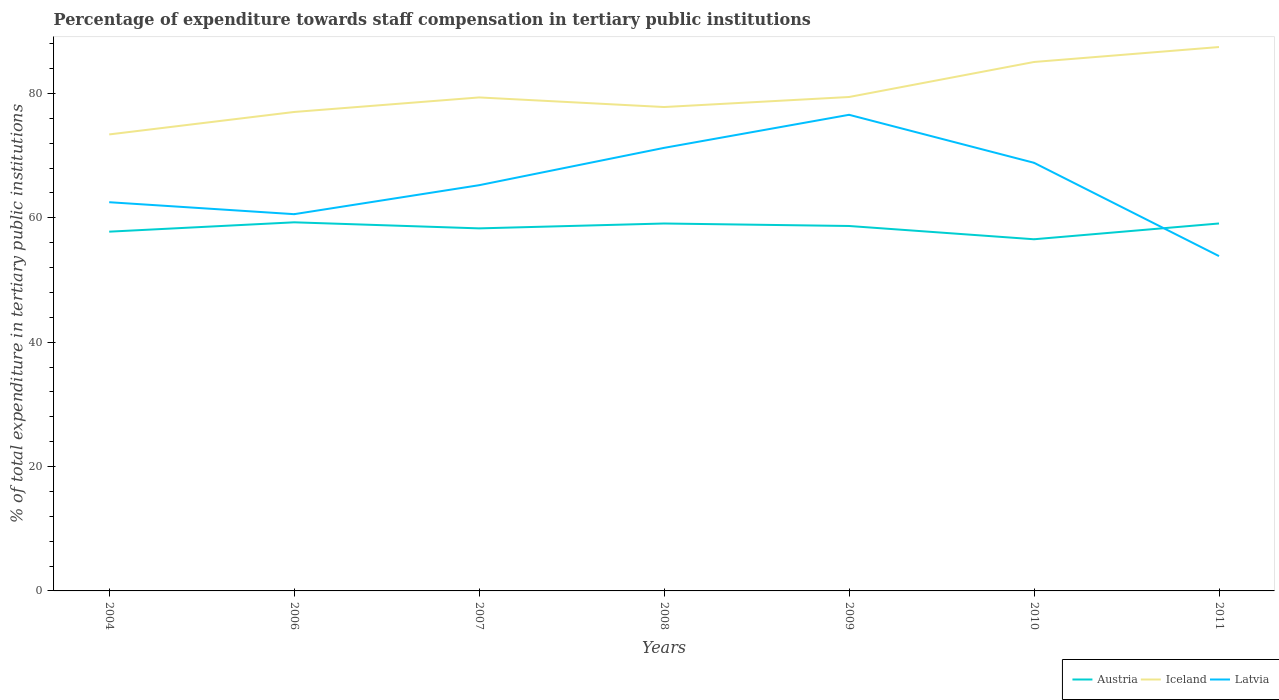How many different coloured lines are there?
Give a very brief answer. 3. Does the line corresponding to Iceland intersect with the line corresponding to Austria?
Provide a succinct answer. No. Across all years, what is the maximum percentage of expenditure towards staff compensation in Iceland?
Provide a short and direct response. 73.4. What is the total percentage of expenditure towards staff compensation in Iceland in the graph?
Make the answer very short. 1.54. What is the difference between the highest and the second highest percentage of expenditure towards staff compensation in Latvia?
Provide a succinct answer. 22.72. What is the difference between the highest and the lowest percentage of expenditure towards staff compensation in Austria?
Your answer should be very brief. 4. Is the percentage of expenditure towards staff compensation in Latvia strictly greater than the percentage of expenditure towards staff compensation in Austria over the years?
Offer a very short reply. No. How many lines are there?
Your answer should be very brief. 3. How many years are there in the graph?
Make the answer very short. 7. Does the graph contain any zero values?
Your response must be concise. No. Does the graph contain grids?
Make the answer very short. No. Where does the legend appear in the graph?
Your response must be concise. Bottom right. What is the title of the graph?
Offer a very short reply. Percentage of expenditure towards staff compensation in tertiary public institutions. What is the label or title of the X-axis?
Ensure brevity in your answer.  Years. What is the label or title of the Y-axis?
Your answer should be compact. % of total expenditure in tertiary public institutions. What is the % of total expenditure in tertiary public institutions in Austria in 2004?
Your answer should be compact. 57.76. What is the % of total expenditure in tertiary public institutions in Iceland in 2004?
Your answer should be compact. 73.4. What is the % of total expenditure in tertiary public institutions of Latvia in 2004?
Your answer should be very brief. 62.5. What is the % of total expenditure in tertiary public institutions in Austria in 2006?
Your answer should be very brief. 59.27. What is the % of total expenditure in tertiary public institutions in Iceland in 2006?
Ensure brevity in your answer.  77.01. What is the % of total expenditure in tertiary public institutions in Latvia in 2006?
Your answer should be very brief. 60.58. What is the % of total expenditure in tertiary public institutions in Austria in 2007?
Give a very brief answer. 58.29. What is the % of total expenditure in tertiary public institutions in Iceland in 2007?
Provide a short and direct response. 79.35. What is the % of total expenditure in tertiary public institutions in Latvia in 2007?
Your response must be concise. 65.24. What is the % of total expenditure in tertiary public institutions in Austria in 2008?
Provide a short and direct response. 59.08. What is the % of total expenditure in tertiary public institutions in Iceland in 2008?
Ensure brevity in your answer.  77.8. What is the % of total expenditure in tertiary public institutions of Latvia in 2008?
Your answer should be very brief. 71.24. What is the % of total expenditure in tertiary public institutions in Austria in 2009?
Your answer should be very brief. 58.68. What is the % of total expenditure in tertiary public institutions in Iceland in 2009?
Ensure brevity in your answer.  79.42. What is the % of total expenditure in tertiary public institutions of Latvia in 2009?
Your answer should be very brief. 76.56. What is the % of total expenditure in tertiary public institutions in Austria in 2010?
Your answer should be compact. 56.54. What is the % of total expenditure in tertiary public institutions in Iceland in 2010?
Provide a succinct answer. 85.05. What is the % of total expenditure in tertiary public institutions of Latvia in 2010?
Give a very brief answer. 68.84. What is the % of total expenditure in tertiary public institutions of Austria in 2011?
Your response must be concise. 59.08. What is the % of total expenditure in tertiary public institutions of Iceland in 2011?
Your answer should be very brief. 87.45. What is the % of total expenditure in tertiary public institutions of Latvia in 2011?
Your response must be concise. 53.84. Across all years, what is the maximum % of total expenditure in tertiary public institutions of Austria?
Your answer should be compact. 59.27. Across all years, what is the maximum % of total expenditure in tertiary public institutions in Iceland?
Ensure brevity in your answer.  87.45. Across all years, what is the maximum % of total expenditure in tertiary public institutions of Latvia?
Ensure brevity in your answer.  76.56. Across all years, what is the minimum % of total expenditure in tertiary public institutions in Austria?
Provide a short and direct response. 56.54. Across all years, what is the minimum % of total expenditure in tertiary public institutions of Iceland?
Ensure brevity in your answer.  73.4. Across all years, what is the minimum % of total expenditure in tertiary public institutions in Latvia?
Offer a terse response. 53.84. What is the total % of total expenditure in tertiary public institutions of Austria in the graph?
Offer a very short reply. 408.7. What is the total % of total expenditure in tertiary public institutions in Iceland in the graph?
Make the answer very short. 559.48. What is the total % of total expenditure in tertiary public institutions of Latvia in the graph?
Give a very brief answer. 458.78. What is the difference between the % of total expenditure in tertiary public institutions of Austria in 2004 and that in 2006?
Give a very brief answer. -1.5. What is the difference between the % of total expenditure in tertiary public institutions of Iceland in 2004 and that in 2006?
Make the answer very short. -3.61. What is the difference between the % of total expenditure in tertiary public institutions of Latvia in 2004 and that in 2006?
Offer a terse response. 1.92. What is the difference between the % of total expenditure in tertiary public institutions of Austria in 2004 and that in 2007?
Keep it short and to the point. -0.53. What is the difference between the % of total expenditure in tertiary public institutions of Iceland in 2004 and that in 2007?
Give a very brief answer. -5.95. What is the difference between the % of total expenditure in tertiary public institutions in Latvia in 2004 and that in 2007?
Give a very brief answer. -2.74. What is the difference between the % of total expenditure in tertiary public institutions of Austria in 2004 and that in 2008?
Your response must be concise. -1.31. What is the difference between the % of total expenditure in tertiary public institutions in Iceland in 2004 and that in 2008?
Provide a succinct answer. -4.41. What is the difference between the % of total expenditure in tertiary public institutions of Latvia in 2004 and that in 2008?
Keep it short and to the point. -8.74. What is the difference between the % of total expenditure in tertiary public institutions of Austria in 2004 and that in 2009?
Ensure brevity in your answer.  -0.91. What is the difference between the % of total expenditure in tertiary public institutions of Iceland in 2004 and that in 2009?
Offer a terse response. -6.02. What is the difference between the % of total expenditure in tertiary public institutions in Latvia in 2004 and that in 2009?
Your answer should be compact. -14.06. What is the difference between the % of total expenditure in tertiary public institutions in Austria in 2004 and that in 2010?
Give a very brief answer. 1.22. What is the difference between the % of total expenditure in tertiary public institutions in Iceland in 2004 and that in 2010?
Offer a very short reply. -11.65. What is the difference between the % of total expenditure in tertiary public institutions in Latvia in 2004 and that in 2010?
Ensure brevity in your answer.  -6.34. What is the difference between the % of total expenditure in tertiary public institutions in Austria in 2004 and that in 2011?
Provide a succinct answer. -1.32. What is the difference between the % of total expenditure in tertiary public institutions in Iceland in 2004 and that in 2011?
Make the answer very short. -14.05. What is the difference between the % of total expenditure in tertiary public institutions of Latvia in 2004 and that in 2011?
Provide a short and direct response. 8.66. What is the difference between the % of total expenditure in tertiary public institutions of Austria in 2006 and that in 2007?
Keep it short and to the point. 0.97. What is the difference between the % of total expenditure in tertiary public institutions of Iceland in 2006 and that in 2007?
Ensure brevity in your answer.  -2.34. What is the difference between the % of total expenditure in tertiary public institutions of Latvia in 2006 and that in 2007?
Your response must be concise. -4.66. What is the difference between the % of total expenditure in tertiary public institutions in Austria in 2006 and that in 2008?
Your answer should be compact. 0.19. What is the difference between the % of total expenditure in tertiary public institutions of Iceland in 2006 and that in 2008?
Provide a short and direct response. -0.79. What is the difference between the % of total expenditure in tertiary public institutions of Latvia in 2006 and that in 2008?
Offer a very short reply. -10.66. What is the difference between the % of total expenditure in tertiary public institutions in Austria in 2006 and that in 2009?
Make the answer very short. 0.59. What is the difference between the % of total expenditure in tertiary public institutions of Iceland in 2006 and that in 2009?
Your answer should be compact. -2.41. What is the difference between the % of total expenditure in tertiary public institutions in Latvia in 2006 and that in 2009?
Your response must be concise. -15.98. What is the difference between the % of total expenditure in tertiary public institutions in Austria in 2006 and that in 2010?
Keep it short and to the point. 2.72. What is the difference between the % of total expenditure in tertiary public institutions of Iceland in 2006 and that in 2010?
Make the answer very short. -8.04. What is the difference between the % of total expenditure in tertiary public institutions in Latvia in 2006 and that in 2010?
Make the answer very short. -8.26. What is the difference between the % of total expenditure in tertiary public institutions in Austria in 2006 and that in 2011?
Your answer should be compact. 0.19. What is the difference between the % of total expenditure in tertiary public institutions in Iceland in 2006 and that in 2011?
Provide a short and direct response. -10.44. What is the difference between the % of total expenditure in tertiary public institutions of Latvia in 2006 and that in 2011?
Your response must be concise. 6.74. What is the difference between the % of total expenditure in tertiary public institutions in Austria in 2007 and that in 2008?
Your answer should be compact. -0.78. What is the difference between the % of total expenditure in tertiary public institutions of Iceland in 2007 and that in 2008?
Your answer should be compact. 1.54. What is the difference between the % of total expenditure in tertiary public institutions of Latvia in 2007 and that in 2008?
Your answer should be compact. -6. What is the difference between the % of total expenditure in tertiary public institutions in Austria in 2007 and that in 2009?
Provide a succinct answer. -0.38. What is the difference between the % of total expenditure in tertiary public institutions in Iceland in 2007 and that in 2009?
Your answer should be compact. -0.07. What is the difference between the % of total expenditure in tertiary public institutions of Latvia in 2007 and that in 2009?
Your response must be concise. -11.32. What is the difference between the % of total expenditure in tertiary public institutions in Austria in 2007 and that in 2010?
Keep it short and to the point. 1.75. What is the difference between the % of total expenditure in tertiary public institutions of Iceland in 2007 and that in 2010?
Provide a succinct answer. -5.7. What is the difference between the % of total expenditure in tertiary public institutions in Latvia in 2007 and that in 2010?
Provide a short and direct response. -3.6. What is the difference between the % of total expenditure in tertiary public institutions of Austria in 2007 and that in 2011?
Your response must be concise. -0.79. What is the difference between the % of total expenditure in tertiary public institutions in Iceland in 2007 and that in 2011?
Your answer should be compact. -8.1. What is the difference between the % of total expenditure in tertiary public institutions of Latvia in 2007 and that in 2011?
Provide a short and direct response. 11.4. What is the difference between the % of total expenditure in tertiary public institutions in Austria in 2008 and that in 2009?
Offer a very short reply. 0.4. What is the difference between the % of total expenditure in tertiary public institutions of Iceland in 2008 and that in 2009?
Your answer should be very brief. -1.61. What is the difference between the % of total expenditure in tertiary public institutions of Latvia in 2008 and that in 2009?
Offer a terse response. -5.32. What is the difference between the % of total expenditure in tertiary public institutions of Austria in 2008 and that in 2010?
Keep it short and to the point. 2.53. What is the difference between the % of total expenditure in tertiary public institutions of Iceland in 2008 and that in 2010?
Your response must be concise. -7.24. What is the difference between the % of total expenditure in tertiary public institutions of Latvia in 2008 and that in 2010?
Your answer should be very brief. 2.4. What is the difference between the % of total expenditure in tertiary public institutions of Austria in 2008 and that in 2011?
Your answer should be very brief. -0. What is the difference between the % of total expenditure in tertiary public institutions in Iceland in 2008 and that in 2011?
Your answer should be compact. -9.65. What is the difference between the % of total expenditure in tertiary public institutions of Latvia in 2008 and that in 2011?
Your answer should be compact. 17.4. What is the difference between the % of total expenditure in tertiary public institutions of Austria in 2009 and that in 2010?
Your answer should be very brief. 2.13. What is the difference between the % of total expenditure in tertiary public institutions of Iceland in 2009 and that in 2010?
Keep it short and to the point. -5.63. What is the difference between the % of total expenditure in tertiary public institutions of Latvia in 2009 and that in 2010?
Ensure brevity in your answer.  7.72. What is the difference between the % of total expenditure in tertiary public institutions in Austria in 2009 and that in 2011?
Your answer should be very brief. -0.4. What is the difference between the % of total expenditure in tertiary public institutions of Iceland in 2009 and that in 2011?
Your answer should be very brief. -8.04. What is the difference between the % of total expenditure in tertiary public institutions in Latvia in 2009 and that in 2011?
Your response must be concise. 22.72. What is the difference between the % of total expenditure in tertiary public institutions in Austria in 2010 and that in 2011?
Your response must be concise. -2.54. What is the difference between the % of total expenditure in tertiary public institutions in Iceland in 2010 and that in 2011?
Give a very brief answer. -2.4. What is the difference between the % of total expenditure in tertiary public institutions in Latvia in 2010 and that in 2011?
Offer a terse response. 15. What is the difference between the % of total expenditure in tertiary public institutions in Austria in 2004 and the % of total expenditure in tertiary public institutions in Iceland in 2006?
Provide a succinct answer. -19.25. What is the difference between the % of total expenditure in tertiary public institutions of Austria in 2004 and the % of total expenditure in tertiary public institutions of Latvia in 2006?
Give a very brief answer. -2.81. What is the difference between the % of total expenditure in tertiary public institutions of Iceland in 2004 and the % of total expenditure in tertiary public institutions of Latvia in 2006?
Your response must be concise. 12.82. What is the difference between the % of total expenditure in tertiary public institutions in Austria in 2004 and the % of total expenditure in tertiary public institutions in Iceland in 2007?
Offer a terse response. -21.58. What is the difference between the % of total expenditure in tertiary public institutions of Austria in 2004 and the % of total expenditure in tertiary public institutions of Latvia in 2007?
Offer a terse response. -7.47. What is the difference between the % of total expenditure in tertiary public institutions of Iceland in 2004 and the % of total expenditure in tertiary public institutions of Latvia in 2007?
Give a very brief answer. 8.16. What is the difference between the % of total expenditure in tertiary public institutions of Austria in 2004 and the % of total expenditure in tertiary public institutions of Iceland in 2008?
Your answer should be compact. -20.04. What is the difference between the % of total expenditure in tertiary public institutions of Austria in 2004 and the % of total expenditure in tertiary public institutions of Latvia in 2008?
Give a very brief answer. -13.48. What is the difference between the % of total expenditure in tertiary public institutions of Iceland in 2004 and the % of total expenditure in tertiary public institutions of Latvia in 2008?
Provide a succinct answer. 2.16. What is the difference between the % of total expenditure in tertiary public institutions in Austria in 2004 and the % of total expenditure in tertiary public institutions in Iceland in 2009?
Give a very brief answer. -21.65. What is the difference between the % of total expenditure in tertiary public institutions of Austria in 2004 and the % of total expenditure in tertiary public institutions of Latvia in 2009?
Keep it short and to the point. -18.79. What is the difference between the % of total expenditure in tertiary public institutions in Iceland in 2004 and the % of total expenditure in tertiary public institutions in Latvia in 2009?
Provide a succinct answer. -3.16. What is the difference between the % of total expenditure in tertiary public institutions of Austria in 2004 and the % of total expenditure in tertiary public institutions of Iceland in 2010?
Keep it short and to the point. -27.28. What is the difference between the % of total expenditure in tertiary public institutions of Austria in 2004 and the % of total expenditure in tertiary public institutions of Latvia in 2010?
Make the answer very short. -11.07. What is the difference between the % of total expenditure in tertiary public institutions of Iceland in 2004 and the % of total expenditure in tertiary public institutions of Latvia in 2010?
Offer a terse response. 4.56. What is the difference between the % of total expenditure in tertiary public institutions of Austria in 2004 and the % of total expenditure in tertiary public institutions of Iceland in 2011?
Offer a terse response. -29.69. What is the difference between the % of total expenditure in tertiary public institutions of Austria in 2004 and the % of total expenditure in tertiary public institutions of Latvia in 2011?
Make the answer very short. 3.93. What is the difference between the % of total expenditure in tertiary public institutions in Iceland in 2004 and the % of total expenditure in tertiary public institutions in Latvia in 2011?
Your answer should be compact. 19.56. What is the difference between the % of total expenditure in tertiary public institutions in Austria in 2006 and the % of total expenditure in tertiary public institutions in Iceland in 2007?
Keep it short and to the point. -20.08. What is the difference between the % of total expenditure in tertiary public institutions of Austria in 2006 and the % of total expenditure in tertiary public institutions of Latvia in 2007?
Offer a terse response. -5.97. What is the difference between the % of total expenditure in tertiary public institutions of Iceland in 2006 and the % of total expenditure in tertiary public institutions of Latvia in 2007?
Keep it short and to the point. 11.77. What is the difference between the % of total expenditure in tertiary public institutions of Austria in 2006 and the % of total expenditure in tertiary public institutions of Iceland in 2008?
Provide a short and direct response. -18.54. What is the difference between the % of total expenditure in tertiary public institutions in Austria in 2006 and the % of total expenditure in tertiary public institutions in Latvia in 2008?
Your answer should be compact. -11.97. What is the difference between the % of total expenditure in tertiary public institutions in Iceland in 2006 and the % of total expenditure in tertiary public institutions in Latvia in 2008?
Your response must be concise. 5.77. What is the difference between the % of total expenditure in tertiary public institutions in Austria in 2006 and the % of total expenditure in tertiary public institutions in Iceland in 2009?
Your answer should be compact. -20.15. What is the difference between the % of total expenditure in tertiary public institutions in Austria in 2006 and the % of total expenditure in tertiary public institutions in Latvia in 2009?
Your response must be concise. -17.29. What is the difference between the % of total expenditure in tertiary public institutions in Iceland in 2006 and the % of total expenditure in tertiary public institutions in Latvia in 2009?
Ensure brevity in your answer.  0.45. What is the difference between the % of total expenditure in tertiary public institutions of Austria in 2006 and the % of total expenditure in tertiary public institutions of Iceland in 2010?
Offer a very short reply. -25.78. What is the difference between the % of total expenditure in tertiary public institutions in Austria in 2006 and the % of total expenditure in tertiary public institutions in Latvia in 2010?
Provide a succinct answer. -9.57. What is the difference between the % of total expenditure in tertiary public institutions in Iceland in 2006 and the % of total expenditure in tertiary public institutions in Latvia in 2010?
Make the answer very short. 8.17. What is the difference between the % of total expenditure in tertiary public institutions in Austria in 2006 and the % of total expenditure in tertiary public institutions in Iceland in 2011?
Provide a short and direct response. -28.18. What is the difference between the % of total expenditure in tertiary public institutions of Austria in 2006 and the % of total expenditure in tertiary public institutions of Latvia in 2011?
Offer a terse response. 5.43. What is the difference between the % of total expenditure in tertiary public institutions of Iceland in 2006 and the % of total expenditure in tertiary public institutions of Latvia in 2011?
Offer a very short reply. 23.17. What is the difference between the % of total expenditure in tertiary public institutions in Austria in 2007 and the % of total expenditure in tertiary public institutions in Iceland in 2008?
Keep it short and to the point. -19.51. What is the difference between the % of total expenditure in tertiary public institutions of Austria in 2007 and the % of total expenditure in tertiary public institutions of Latvia in 2008?
Your response must be concise. -12.95. What is the difference between the % of total expenditure in tertiary public institutions of Iceland in 2007 and the % of total expenditure in tertiary public institutions of Latvia in 2008?
Ensure brevity in your answer.  8.11. What is the difference between the % of total expenditure in tertiary public institutions in Austria in 2007 and the % of total expenditure in tertiary public institutions in Iceland in 2009?
Offer a terse response. -21.12. What is the difference between the % of total expenditure in tertiary public institutions of Austria in 2007 and the % of total expenditure in tertiary public institutions of Latvia in 2009?
Provide a short and direct response. -18.26. What is the difference between the % of total expenditure in tertiary public institutions in Iceland in 2007 and the % of total expenditure in tertiary public institutions in Latvia in 2009?
Give a very brief answer. 2.79. What is the difference between the % of total expenditure in tertiary public institutions in Austria in 2007 and the % of total expenditure in tertiary public institutions in Iceland in 2010?
Your response must be concise. -26.75. What is the difference between the % of total expenditure in tertiary public institutions of Austria in 2007 and the % of total expenditure in tertiary public institutions of Latvia in 2010?
Make the answer very short. -10.54. What is the difference between the % of total expenditure in tertiary public institutions of Iceland in 2007 and the % of total expenditure in tertiary public institutions of Latvia in 2010?
Offer a very short reply. 10.51. What is the difference between the % of total expenditure in tertiary public institutions in Austria in 2007 and the % of total expenditure in tertiary public institutions in Iceland in 2011?
Provide a succinct answer. -29.16. What is the difference between the % of total expenditure in tertiary public institutions of Austria in 2007 and the % of total expenditure in tertiary public institutions of Latvia in 2011?
Offer a very short reply. 4.46. What is the difference between the % of total expenditure in tertiary public institutions in Iceland in 2007 and the % of total expenditure in tertiary public institutions in Latvia in 2011?
Offer a very short reply. 25.51. What is the difference between the % of total expenditure in tertiary public institutions in Austria in 2008 and the % of total expenditure in tertiary public institutions in Iceland in 2009?
Your answer should be compact. -20.34. What is the difference between the % of total expenditure in tertiary public institutions in Austria in 2008 and the % of total expenditure in tertiary public institutions in Latvia in 2009?
Offer a very short reply. -17.48. What is the difference between the % of total expenditure in tertiary public institutions in Iceland in 2008 and the % of total expenditure in tertiary public institutions in Latvia in 2009?
Offer a very short reply. 1.25. What is the difference between the % of total expenditure in tertiary public institutions in Austria in 2008 and the % of total expenditure in tertiary public institutions in Iceland in 2010?
Keep it short and to the point. -25.97. What is the difference between the % of total expenditure in tertiary public institutions of Austria in 2008 and the % of total expenditure in tertiary public institutions of Latvia in 2010?
Make the answer very short. -9.76. What is the difference between the % of total expenditure in tertiary public institutions of Iceland in 2008 and the % of total expenditure in tertiary public institutions of Latvia in 2010?
Your response must be concise. 8.97. What is the difference between the % of total expenditure in tertiary public institutions in Austria in 2008 and the % of total expenditure in tertiary public institutions in Iceland in 2011?
Ensure brevity in your answer.  -28.38. What is the difference between the % of total expenditure in tertiary public institutions of Austria in 2008 and the % of total expenditure in tertiary public institutions of Latvia in 2011?
Offer a very short reply. 5.24. What is the difference between the % of total expenditure in tertiary public institutions in Iceland in 2008 and the % of total expenditure in tertiary public institutions in Latvia in 2011?
Keep it short and to the point. 23.97. What is the difference between the % of total expenditure in tertiary public institutions of Austria in 2009 and the % of total expenditure in tertiary public institutions of Iceland in 2010?
Keep it short and to the point. -26.37. What is the difference between the % of total expenditure in tertiary public institutions in Austria in 2009 and the % of total expenditure in tertiary public institutions in Latvia in 2010?
Provide a short and direct response. -10.16. What is the difference between the % of total expenditure in tertiary public institutions of Iceland in 2009 and the % of total expenditure in tertiary public institutions of Latvia in 2010?
Make the answer very short. 10.58. What is the difference between the % of total expenditure in tertiary public institutions in Austria in 2009 and the % of total expenditure in tertiary public institutions in Iceland in 2011?
Your answer should be compact. -28.78. What is the difference between the % of total expenditure in tertiary public institutions of Austria in 2009 and the % of total expenditure in tertiary public institutions of Latvia in 2011?
Your answer should be very brief. 4.84. What is the difference between the % of total expenditure in tertiary public institutions of Iceland in 2009 and the % of total expenditure in tertiary public institutions of Latvia in 2011?
Provide a short and direct response. 25.58. What is the difference between the % of total expenditure in tertiary public institutions in Austria in 2010 and the % of total expenditure in tertiary public institutions in Iceland in 2011?
Ensure brevity in your answer.  -30.91. What is the difference between the % of total expenditure in tertiary public institutions of Austria in 2010 and the % of total expenditure in tertiary public institutions of Latvia in 2011?
Your answer should be compact. 2.71. What is the difference between the % of total expenditure in tertiary public institutions in Iceland in 2010 and the % of total expenditure in tertiary public institutions in Latvia in 2011?
Provide a succinct answer. 31.21. What is the average % of total expenditure in tertiary public institutions in Austria per year?
Your response must be concise. 58.39. What is the average % of total expenditure in tertiary public institutions of Iceland per year?
Ensure brevity in your answer.  79.93. What is the average % of total expenditure in tertiary public institutions of Latvia per year?
Ensure brevity in your answer.  65.54. In the year 2004, what is the difference between the % of total expenditure in tertiary public institutions in Austria and % of total expenditure in tertiary public institutions in Iceland?
Your response must be concise. -15.63. In the year 2004, what is the difference between the % of total expenditure in tertiary public institutions of Austria and % of total expenditure in tertiary public institutions of Latvia?
Your answer should be compact. -4.74. In the year 2004, what is the difference between the % of total expenditure in tertiary public institutions of Iceland and % of total expenditure in tertiary public institutions of Latvia?
Offer a terse response. 10.9. In the year 2006, what is the difference between the % of total expenditure in tertiary public institutions in Austria and % of total expenditure in tertiary public institutions in Iceland?
Your response must be concise. -17.74. In the year 2006, what is the difference between the % of total expenditure in tertiary public institutions of Austria and % of total expenditure in tertiary public institutions of Latvia?
Your answer should be very brief. -1.31. In the year 2006, what is the difference between the % of total expenditure in tertiary public institutions in Iceland and % of total expenditure in tertiary public institutions in Latvia?
Offer a terse response. 16.43. In the year 2007, what is the difference between the % of total expenditure in tertiary public institutions of Austria and % of total expenditure in tertiary public institutions of Iceland?
Offer a terse response. -21.05. In the year 2007, what is the difference between the % of total expenditure in tertiary public institutions in Austria and % of total expenditure in tertiary public institutions in Latvia?
Provide a short and direct response. -6.94. In the year 2007, what is the difference between the % of total expenditure in tertiary public institutions of Iceland and % of total expenditure in tertiary public institutions of Latvia?
Offer a very short reply. 14.11. In the year 2008, what is the difference between the % of total expenditure in tertiary public institutions of Austria and % of total expenditure in tertiary public institutions of Iceland?
Provide a succinct answer. -18.73. In the year 2008, what is the difference between the % of total expenditure in tertiary public institutions in Austria and % of total expenditure in tertiary public institutions in Latvia?
Your answer should be very brief. -12.16. In the year 2008, what is the difference between the % of total expenditure in tertiary public institutions of Iceland and % of total expenditure in tertiary public institutions of Latvia?
Provide a succinct answer. 6.56. In the year 2009, what is the difference between the % of total expenditure in tertiary public institutions in Austria and % of total expenditure in tertiary public institutions in Iceland?
Provide a short and direct response. -20.74. In the year 2009, what is the difference between the % of total expenditure in tertiary public institutions in Austria and % of total expenditure in tertiary public institutions in Latvia?
Provide a succinct answer. -17.88. In the year 2009, what is the difference between the % of total expenditure in tertiary public institutions in Iceland and % of total expenditure in tertiary public institutions in Latvia?
Your answer should be very brief. 2.86. In the year 2010, what is the difference between the % of total expenditure in tertiary public institutions of Austria and % of total expenditure in tertiary public institutions of Iceland?
Provide a short and direct response. -28.5. In the year 2010, what is the difference between the % of total expenditure in tertiary public institutions in Austria and % of total expenditure in tertiary public institutions in Latvia?
Offer a terse response. -12.29. In the year 2010, what is the difference between the % of total expenditure in tertiary public institutions of Iceland and % of total expenditure in tertiary public institutions of Latvia?
Your answer should be very brief. 16.21. In the year 2011, what is the difference between the % of total expenditure in tertiary public institutions of Austria and % of total expenditure in tertiary public institutions of Iceland?
Offer a very short reply. -28.37. In the year 2011, what is the difference between the % of total expenditure in tertiary public institutions in Austria and % of total expenditure in tertiary public institutions in Latvia?
Offer a very short reply. 5.24. In the year 2011, what is the difference between the % of total expenditure in tertiary public institutions in Iceland and % of total expenditure in tertiary public institutions in Latvia?
Offer a terse response. 33.62. What is the ratio of the % of total expenditure in tertiary public institutions in Austria in 2004 to that in 2006?
Ensure brevity in your answer.  0.97. What is the ratio of the % of total expenditure in tertiary public institutions in Iceland in 2004 to that in 2006?
Your answer should be very brief. 0.95. What is the ratio of the % of total expenditure in tertiary public institutions of Latvia in 2004 to that in 2006?
Your answer should be compact. 1.03. What is the ratio of the % of total expenditure in tertiary public institutions in Austria in 2004 to that in 2007?
Give a very brief answer. 0.99. What is the ratio of the % of total expenditure in tertiary public institutions in Iceland in 2004 to that in 2007?
Your answer should be compact. 0.93. What is the ratio of the % of total expenditure in tertiary public institutions of Latvia in 2004 to that in 2007?
Your response must be concise. 0.96. What is the ratio of the % of total expenditure in tertiary public institutions in Austria in 2004 to that in 2008?
Provide a succinct answer. 0.98. What is the ratio of the % of total expenditure in tertiary public institutions of Iceland in 2004 to that in 2008?
Offer a very short reply. 0.94. What is the ratio of the % of total expenditure in tertiary public institutions of Latvia in 2004 to that in 2008?
Your answer should be compact. 0.88. What is the ratio of the % of total expenditure in tertiary public institutions in Austria in 2004 to that in 2009?
Your response must be concise. 0.98. What is the ratio of the % of total expenditure in tertiary public institutions of Iceland in 2004 to that in 2009?
Keep it short and to the point. 0.92. What is the ratio of the % of total expenditure in tertiary public institutions in Latvia in 2004 to that in 2009?
Provide a short and direct response. 0.82. What is the ratio of the % of total expenditure in tertiary public institutions in Austria in 2004 to that in 2010?
Provide a short and direct response. 1.02. What is the ratio of the % of total expenditure in tertiary public institutions in Iceland in 2004 to that in 2010?
Your answer should be very brief. 0.86. What is the ratio of the % of total expenditure in tertiary public institutions in Latvia in 2004 to that in 2010?
Provide a short and direct response. 0.91. What is the ratio of the % of total expenditure in tertiary public institutions of Austria in 2004 to that in 2011?
Make the answer very short. 0.98. What is the ratio of the % of total expenditure in tertiary public institutions of Iceland in 2004 to that in 2011?
Give a very brief answer. 0.84. What is the ratio of the % of total expenditure in tertiary public institutions of Latvia in 2004 to that in 2011?
Provide a succinct answer. 1.16. What is the ratio of the % of total expenditure in tertiary public institutions in Austria in 2006 to that in 2007?
Ensure brevity in your answer.  1.02. What is the ratio of the % of total expenditure in tertiary public institutions in Iceland in 2006 to that in 2007?
Offer a very short reply. 0.97. What is the ratio of the % of total expenditure in tertiary public institutions in Latvia in 2006 to that in 2007?
Your answer should be very brief. 0.93. What is the ratio of the % of total expenditure in tertiary public institutions of Latvia in 2006 to that in 2008?
Give a very brief answer. 0.85. What is the ratio of the % of total expenditure in tertiary public institutions of Austria in 2006 to that in 2009?
Your answer should be compact. 1.01. What is the ratio of the % of total expenditure in tertiary public institutions in Iceland in 2006 to that in 2009?
Ensure brevity in your answer.  0.97. What is the ratio of the % of total expenditure in tertiary public institutions in Latvia in 2006 to that in 2009?
Give a very brief answer. 0.79. What is the ratio of the % of total expenditure in tertiary public institutions in Austria in 2006 to that in 2010?
Provide a short and direct response. 1.05. What is the ratio of the % of total expenditure in tertiary public institutions in Iceland in 2006 to that in 2010?
Make the answer very short. 0.91. What is the ratio of the % of total expenditure in tertiary public institutions in Iceland in 2006 to that in 2011?
Offer a very short reply. 0.88. What is the ratio of the % of total expenditure in tertiary public institutions of Latvia in 2006 to that in 2011?
Your response must be concise. 1.13. What is the ratio of the % of total expenditure in tertiary public institutions in Austria in 2007 to that in 2008?
Your response must be concise. 0.99. What is the ratio of the % of total expenditure in tertiary public institutions of Iceland in 2007 to that in 2008?
Your answer should be very brief. 1.02. What is the ratio of the % of total expenditure in tertiary public institutions of Latvia in 2007 to that in 2008?
Offer a terse response. 0.92. What is the ratio of the % of total expenditure in tertiary public institutions of Latvia in 2007 to that in 2009?
Offer a terse response. 0.85. What is the ratio of the % of total expenditure in tertiary public institutions of Austria in 2007 to that in 2010?
Your answer should be very brief. 1.03. What is the ratio of the % of total expenditure in tertiary public institutions in Iceland in 2007 to that in 2010?
Your response must be concise. 0.93. What is the ratio of the % of total expenditure in tertiary public institutions in Latvia in 2007 to that in 2010?
Your answer should be very brief. 0.95. What is the ratio of the % of total expenditure in tertiary public institutions in Austria in 2007 to that in 2011?
Provide a succinct answer. 0.99. What is the ratio of the % of total expenditure in tertiary public institutions in Iceland in 2007 to that in 2011?
Keep it short and to the point. 0.91. What is the ratio of the % of total expenditure in tertiary public institutions in Latvia in 2007 to that in 2011?
Your response must be concise. 1.21. What is the ratio of the % of total expenditure in tertiary public institutions in Austria in 2008 to that in 2009?
Give a very brief answer. 1.01. What is the ratio of the % of total expenditure in tertiary public institutions of Iceland in 2008 to that in 2009?
Ensure brevity in your answer.  0.98. What is the ratio of the % of total expenditure in tertiary public institutions of Latvia in 2008 to that in 2009?
Offer a terse response. 0.93. What is the ratio of the % of total expenditure in tertiary public institutions of Austria in 2008 to that in 2010?
Your answer should be very brief. 1.04. What is the ratio of the % of total expenditure in tertiary public institutions in Iceland in 2008 to that in 2010?
Keep it short and to the point. 0.91. What is the ratio of the % of total expenditure in tertiary public institutions in Latvia in 2008 to that in 2010?
Give a very brief answer. 1.03. What is the ratio of the % of total expenditure in tertiary public institutions in Iceland in 2008 to that in 2011?
Offer a very short reply. 0.89. What is the ratio of the % of total expenditure in tertiary public institutions of Latvia in 2008 to that in 2011?
Keep it short and to the point. 1.32. What is the ratio of the % of total expenditure in tertiary public institutions of Austria in 2009 to that in 2010?
Keep it short and to the point. 1.04. What is the ratio of the % of total expenditure in tertiary public institutions in Iceland in 2009 to that in 2010?
Give a very brief answer. 0.93. What is the ratio of the % of total expenditure in tertiary public institutions in Latvia in 2009 to that in 2010?
Offer a terse response. 1.11. What is the ratio of the % of total expenditure in tertiary public institutions of Austria in 2009 to that in 2011?
Offer a terse response. 0.99. What is the ratio of the % of total expenditure in tertiary public institutions of Iceland in 2009 to that in 2011?
Your response must be concise. 0.91. What is the ratio of the % of total expenditure in tertiary public institutions of Latvia in 2009 to that in 2011?
Keep it short and to the point. 1.42. What is the ratio of the % of total expenditure in tertiary public institutions in Iceland in 2010 to that in 2011?
Your response must be concise. 0.97. What is the ratio of the % of total expenditure in tertiary public institutions of Latvia in 2010 to that in 2011?
Keep it short and to the point. 1.28. What is the difference between the highest and the second highest % of total expenditure in tertiary public institutions of Austria?
Your answer should be compact. 0.19. What is the difference between the highest and the second highest % of total expenditure in tertiary public institutions in Iceland?
Your answer should be very brief. 2.4. What is the difference between the highest and the second highest % of total expenditure in tertiary public institutions in Latvia?
Offer a very short reply. 5.32. What is the difference between the highest and the lowest % of total expenditure in tertiary public institutions in Austria?
Make the answer very short. 2.72. What is the difference between the highest and the lowest % of total expenditure in tertiary public institutions of Iceland?
Keep it short and to the point. 14.05. What is the difference between the highest and the lowest % of total expenditure in tertiary public institutions of Latvia?
Your response must be concise. 22.72. 